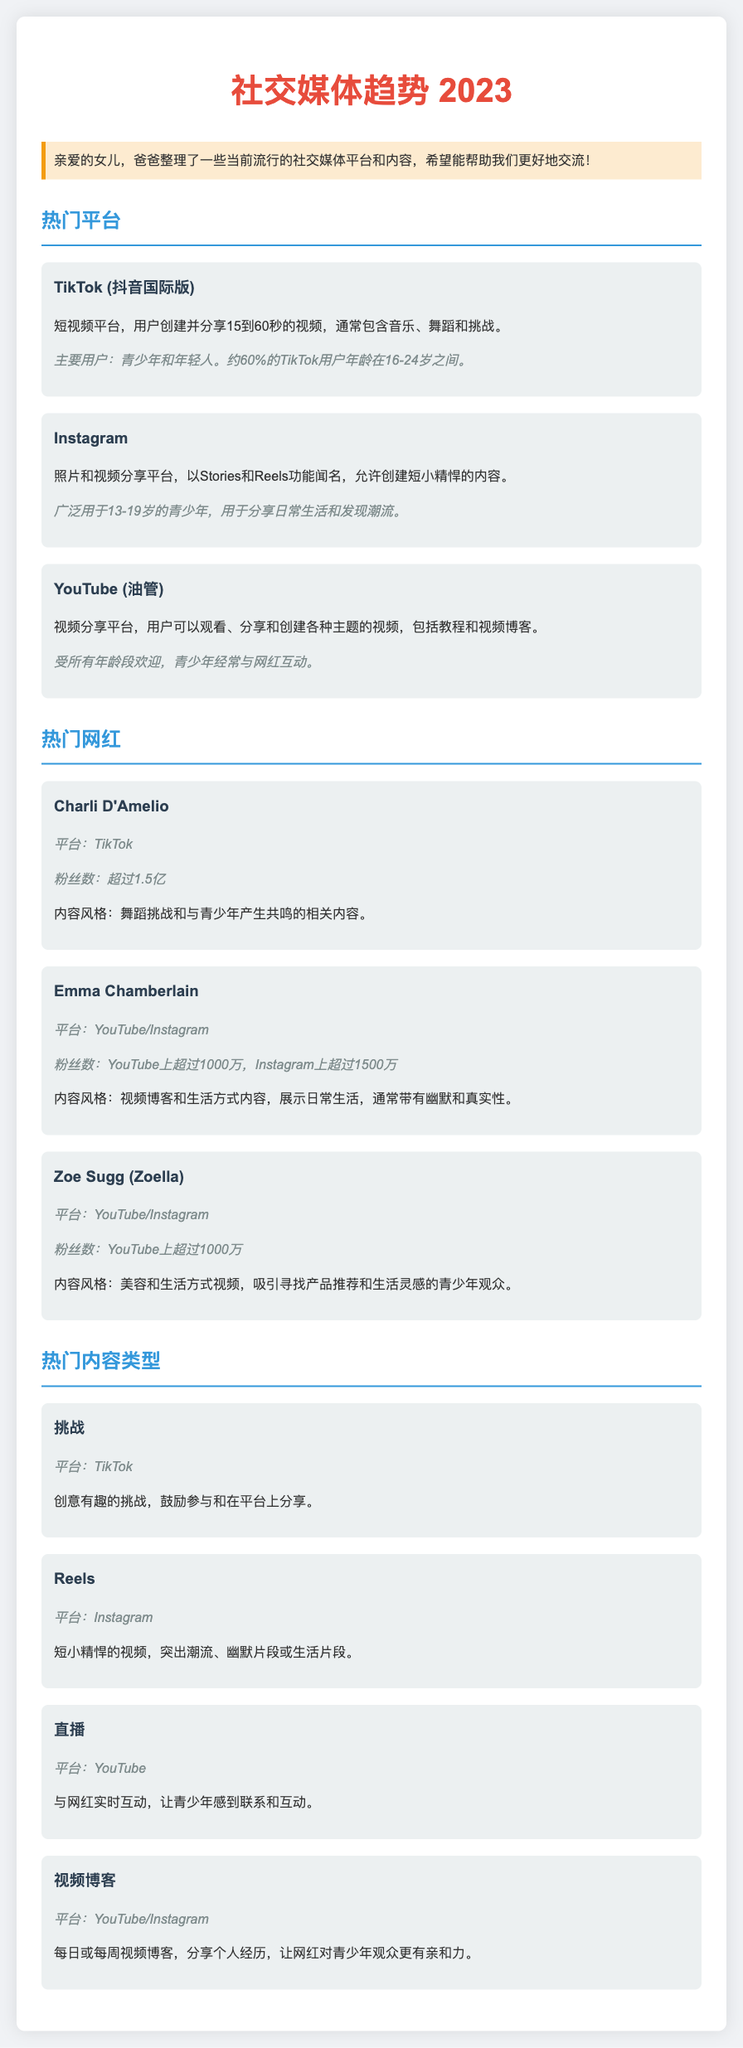what is the main platform highlighted for short videos? The document mentions TikTok as a major platform for short videos, featuring user-generated content.
Answer: TikTok what percentage of TikTok users are aged 16-24? The document states that approximately 60% of TikTok users fall within the 16-24 age range.
Answer: 60% who is the most followed influencer on TikTok? Charli D'Amelio is indicated as the most followed influencer on TikTok in the document.
Answer: Charli D'Amelio which platform is associated with video blogs? The document mentions both YouTube and Instagram as platforms where video blogs are shared.
Answer: YouTube/Instagram what type of content is emphasized in Instagram's Reels? The document describes Reels as highlighting trends, humor, or life snippets in short videos.
Answer: Trends, humor, life snippets how many followers does Emma Chamberlain have on YouTube? The document states that Emma Chamberlain has over 10 million followers on YouTube.
Answer: 超过1000万 what is the main purpose of challenges on TikTok? The document outlines that challenges on TikTok encourage participation and sharing on the platform.
Answer: Encourage participation what type of content do Zoe Sugg's videos primarily focus on? According to the document, Zoe Sugg's videos mainly focus on beauty and lifestyle topics.
Answer: 美容和生活方式 which influencer creates content that includes humor and authenticity? The document mentions that Emma Chamberlain's content style includes humor and authenticity.
Answer: Emma Chamberlain 